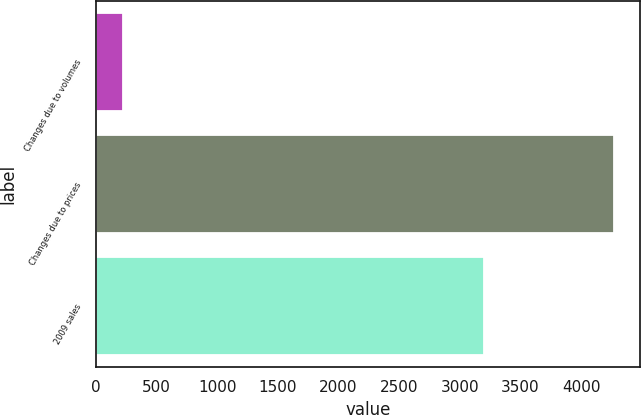Convert chart. <chart><loc_0><loc_0><loc_500><loc_500><bar_chart><fcel>Changes due to volumes<fcel>Changes due to prices<fcel>2009 sales<nl><fcel>222<fcel>4269<fcel>3197<nl></chart> 